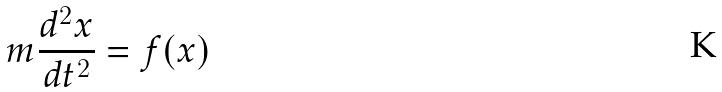<formula> <loc_0><loc_0><loc_500><loc_500>m \frac { d ^ { 2 } x } { d t ^ { 2 } } = f ( x )</formula> 